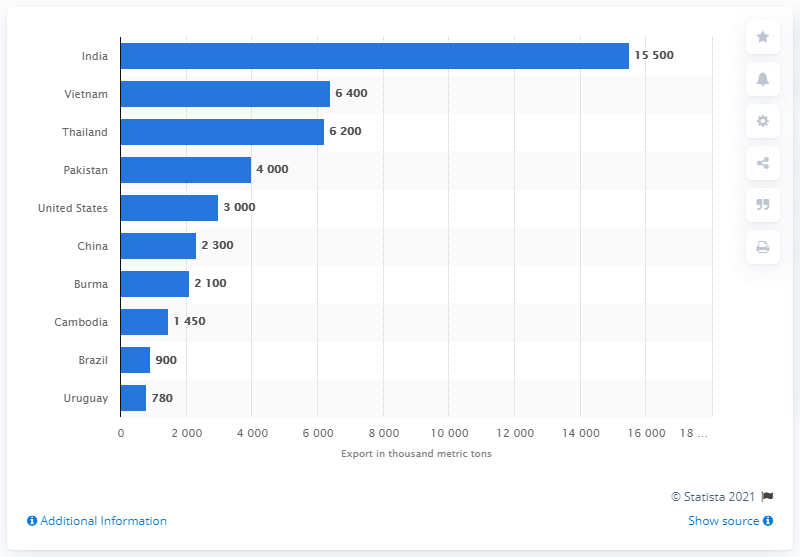List a handful of essential elements in this visual. India had the highest export volume of rice in 2020, accounting for a significant percentage of the global rice exports. Vietnam is the second largest rice exporter in the world. 